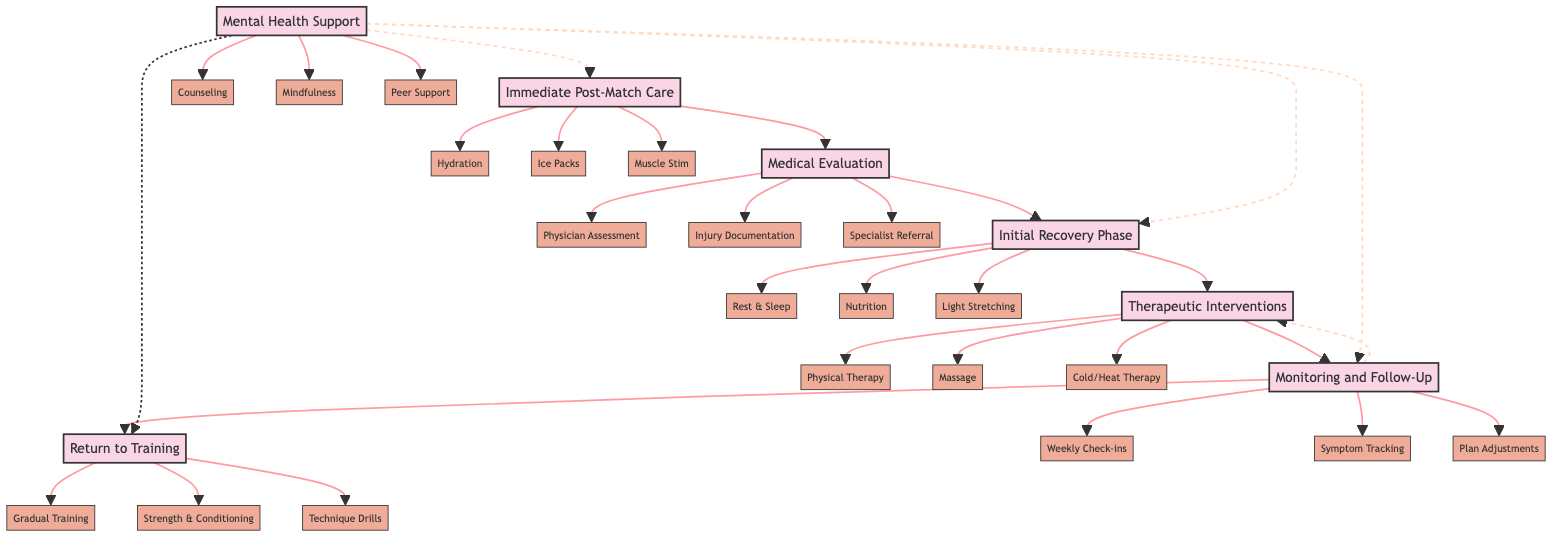What is the first step in the recovery process? The diagram shows that the first step in the recovery process is "Immediate Post-Match Care." This is identified by starting at the beginning of the flow from the top node.
Answer: Immediate Post-Match Care How many components are listed under "Therapeutic Interventions"? The diagram indicates that there are three components listed under "Therapeutic Interventions": "Physical Therapy Sessions," "Massage Therapy," and "Cold and Heat Therapy." This can be counted directly from the node connected to the step.
Answer: 3 What is one component of "Monitoring and Follow-Up"? Under "Monitoring and Follow-Up," one of the components is "Weekly Check-ins with Athletic Trainer." This can be found by looking at the components branching off from this step.
Answer: Weekly Check-ins with Athletic Trainer What step comes after "Medical Evaluation"? Following the flow in the diagram, "Initial Recovery Phase" is the step that comes directly after "Medical Evaluation." This is determined by tracing the path from one step to the next.
Answer: Initial Recovery Phase What is the last element in the recovery process? The last element in the recovery process as indicated in the diagram is "Return to Training." This can be found by looking at the last node connected in the sequence of steps.
Answer: Return to Training How does "Mental Health Support" relate to the recovery process? "Mental Health Support" is connected to multiple steps in the recovery process. It has dashed lines leading to "Immediate Post-Match Care," "Initial Recovery Phase," "Monitoring and Follow-Up," and "Return to Training," indicating its integration throughout the process.
Answer: Integrated support throughout the process 